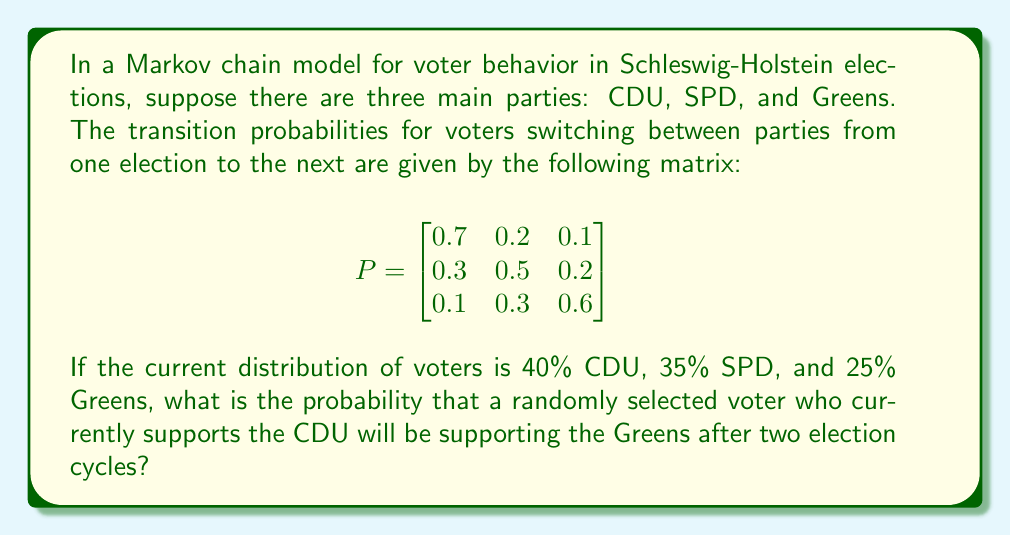Help me with this question. Let's approach this step-by-step:

1) First, we need to understand what the question is asking. We're looking for the probability of a CDU voter switching to the Greens after two transitions (election cycles).

2) In a Markov chain, to find the probabilities after two transitions, we need to multiply the transition matrix by itself:

   $$P^2 = P \times P = \begin{bmatrix}
   0.7 & 0.2 & 0.1 \\
   0.3 & 0.5 & 0.2 \\
   0.1 & 0.3 & 0.6
   \end{bmatrix} \times \begin{bmatrix}
   0.7 & 0.2 & 0.1 \\
   0.3 & 0.5 & 0.2 \\
   0.1 & 0.3 & 0.6
   \end{bmatrix}$$

3) Let's perform this matrix multiplication:

   $$P^2 = \begin{bmatrix}
   (0.7)(0.7) + (0.2)(0.3) + (0.1)(0.1) & ... & ... \\
   ... & ... & ... \\
   ... & ... & ...
   \end{bmatrix}$$

4) After completing the multiplication, we get:

   $$P^2 = \begin{bmatrix}
   0.55 & 0.25 & 0.20 \\
   0.37 & 0.41 & 0.22 \\
   0.22 & 0.39 & 0.39
   \end{bmatrix}$$

5) The probability we're looking for is the element in the first row (CDU) and third column (Greens) of this new matrix.

Therefore, the probability that a current CDU voter will support the Greens after two election cycles is 0.20 or 20%.
Answer: 0.20 